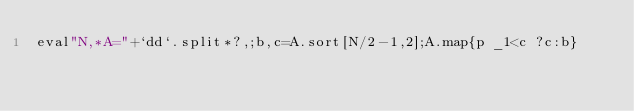<code> <loc_0><loc_0><loc_500><loc_500><_Ruby_>eval"N,*A="+`dd`.split*?,;b,c=A.sort[N/2-1,2];A.map{p _1<c ?c:b}</code> 